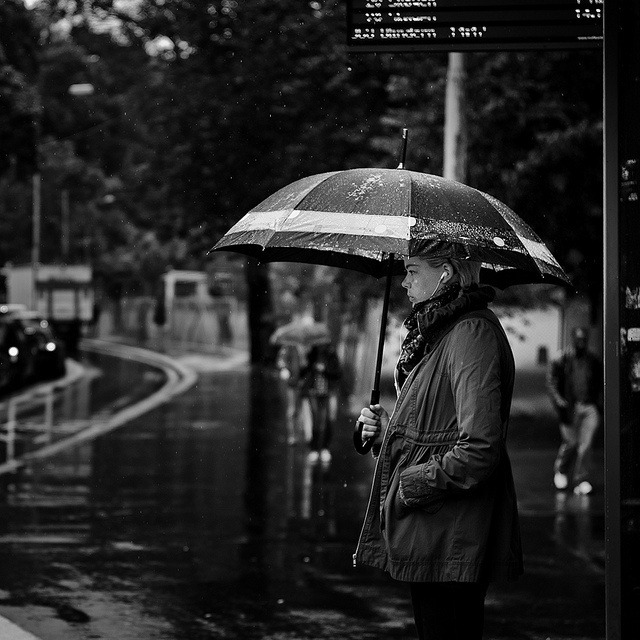Describe the objects in this image and their specific colors. I can see people in black, gray, and lightgray tones, umbrella in black, gray, darkgray, and lightgray tones, people in black, gray, darkgray, and lightgray tones, truck in gray, black, and darkgray tones, and people in black, gray, darkgray, and lightgray tones in this image. 